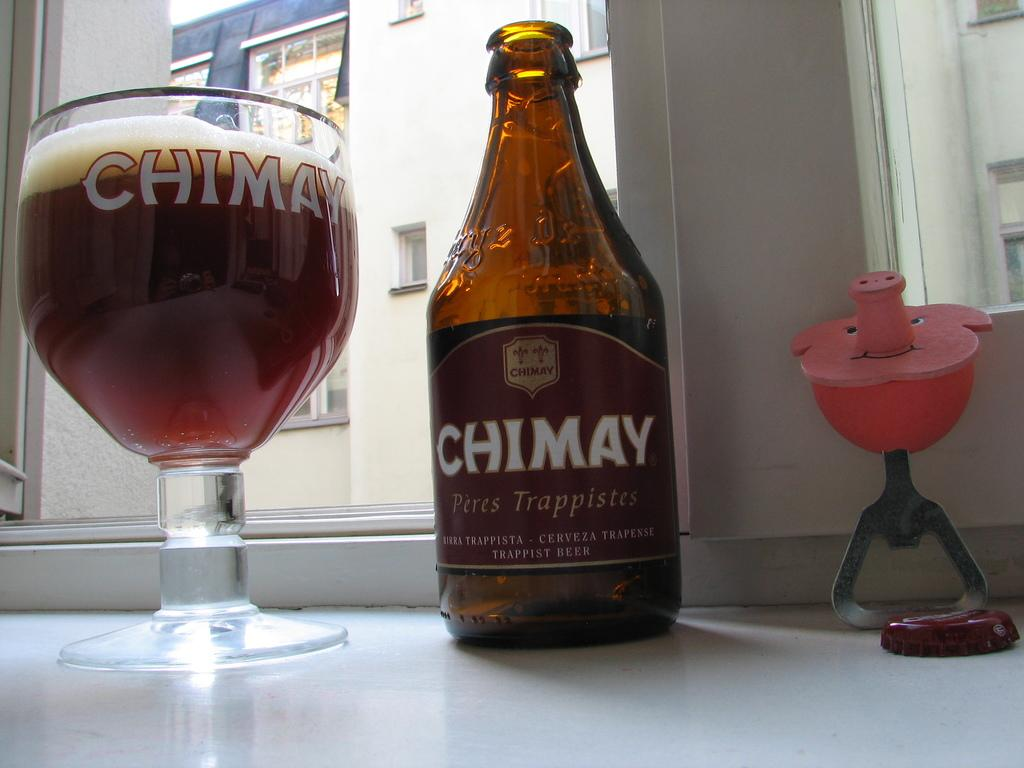Provide a one-sentence caption for the provided image. A bottle of Chimay sits next to a Chimay glass. 